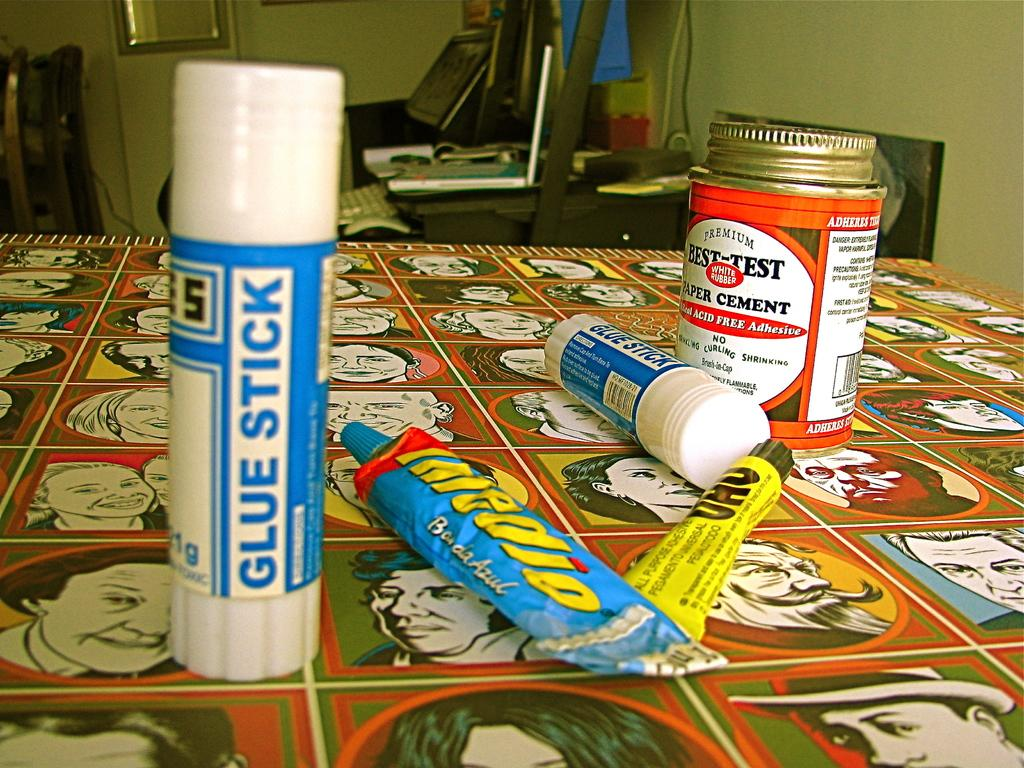<image>
Share a concise interpretation of the image provided. a blue and white item that has glue stick written on it 